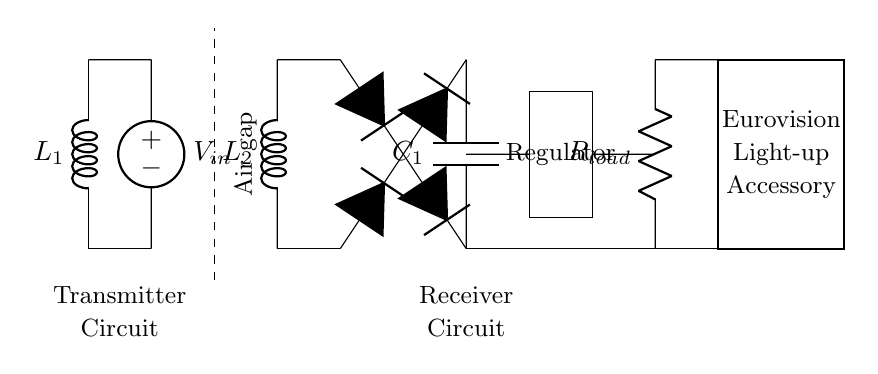What type of circuit is this? This is a wireless charging circuit, which consists of a transmitter and a receiver section for transferring energy wirelessly. The presence of coils, a rectifier bridge, and a regulator indicates this function.
Answer: Wireless charging What component represents energy storage in the receiver circuit? The smoothing capacitor (C1) is the component that stores energy in the receiver circuit. It smooths the output voltage from the rectifier bridge before it reaches the load.
Answer: C1 How many diodes are in the rectifier bridge? There are four diodes in the rectifier bridge, which is represented in the circuit by the three D symbols. The bridge configuration allows conversion of AC to DC.
Answer: Four What does "R_load" represent in the circuit? "R_load" represents the load resistance that simulates the connected device, in this case, the Eurovision light-up accessory. It consumes the output power delivered by the circuit.
Answer: Load resistance What is the purpose of the voltage regulator in the circuit? The voltage regulator ensures that the output voltage remains stable and within a required range for the connected load. It regulates the voltage output from the smoothing capacitor.
Answer: Stabilization What is the function of "L1" and "L2" in the circuit? "L1" and "L2" are the wireless charging coils that create a magnetic field for the transfer of energy from the transmitter to the receiver. They are essential for wireless energy coupling.
Answer: Energy transfer 